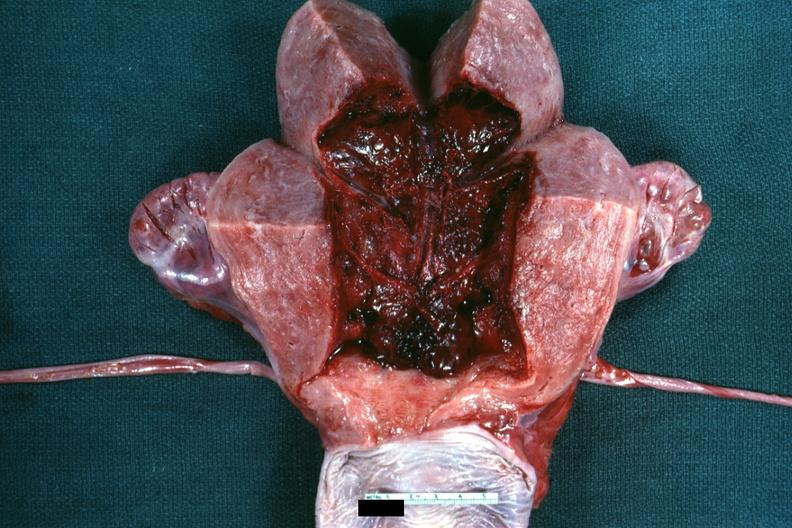when does this image show 18 hours?
Answer the question using a single word or phrase. After cesarean section 